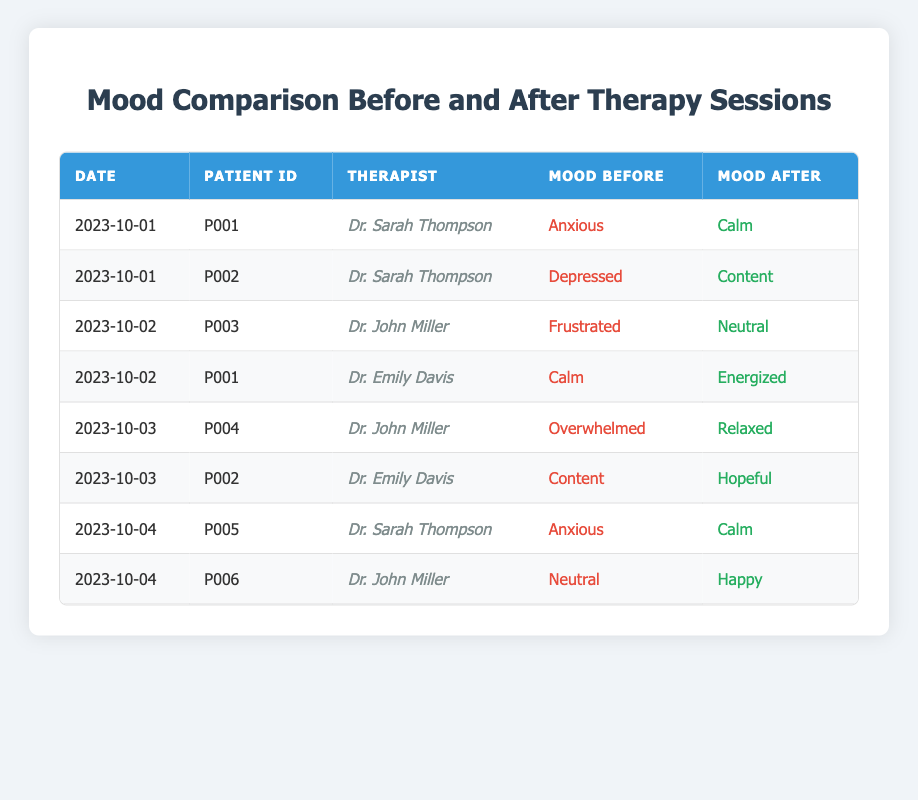What mood did patient P001 report before their session on 2023-10-01? According to the table, for the session date 2023-10-01, patient P001 had a mood rating of "Anxious" before the session.
Answer: Anxious How many total sessions are recorded in the table? The table lists a total of 8 sessions with different patients and their respective moods. Counting each row confirms this total.
Answer: 8 What was the mood change experienced by patient P002 from the session on 2023-10-01 to 2023-10-03? For patient P002, on 2023-10-01 their mood changed from "Depressed" to "Content," and on 2023-10-03 it changed from "Content" to "Hopeful." The overall change from "Depressed" to "Hopeful" indicates improvement.
Answer: Improved from Depressed to Hopeful Did Dr. John Miller supervise patient P004 during their session? Looking at the table, patient P004 had their session supervised by Dr. John Miller on 2023-10-03; so this statement is true.
Answer: Yes What is the average mood before the sessions listed in the table? The moods before the sessions are categorized qualitatively. However, we can assign numerical values, where Anxious = 1, Calm = 2, Content = 3, Frustrated = 1, Overwhelmed = 1, Neutral = 2, Happy = 3, and Energized = 4. Summing these values gives a total of 17, and with 8 sessions, the average is 17/8 = 2.125, which signifies a mood rating leaning towards Calm.
Answer: 2.125 Which patient had the most significant improvement in mood after their session? Analyzing the table, patient P004 went from "Overwhelmed" to "Relaxed," indicating a significant change of mood, which can be interpreted as a substantial improvement, compared to other patients.
Answer: Patient P004 On which date did Dr. Sarah Thompson oversee a session where a patient went from Anxious to Calm? By reviewing the table, on 2023-10-01 Dr. Sarah Thompson's session with patient P001 reflects mood change from "Anxious" to "Calm."
Answer: 2023-10-01 How many patients reported being "Neutral" before their sessions? Referring to the table, patient P003 and patient P006 both reported a "Neutral" mood before their sessions, totaling 2 patients.
Answer: 2 